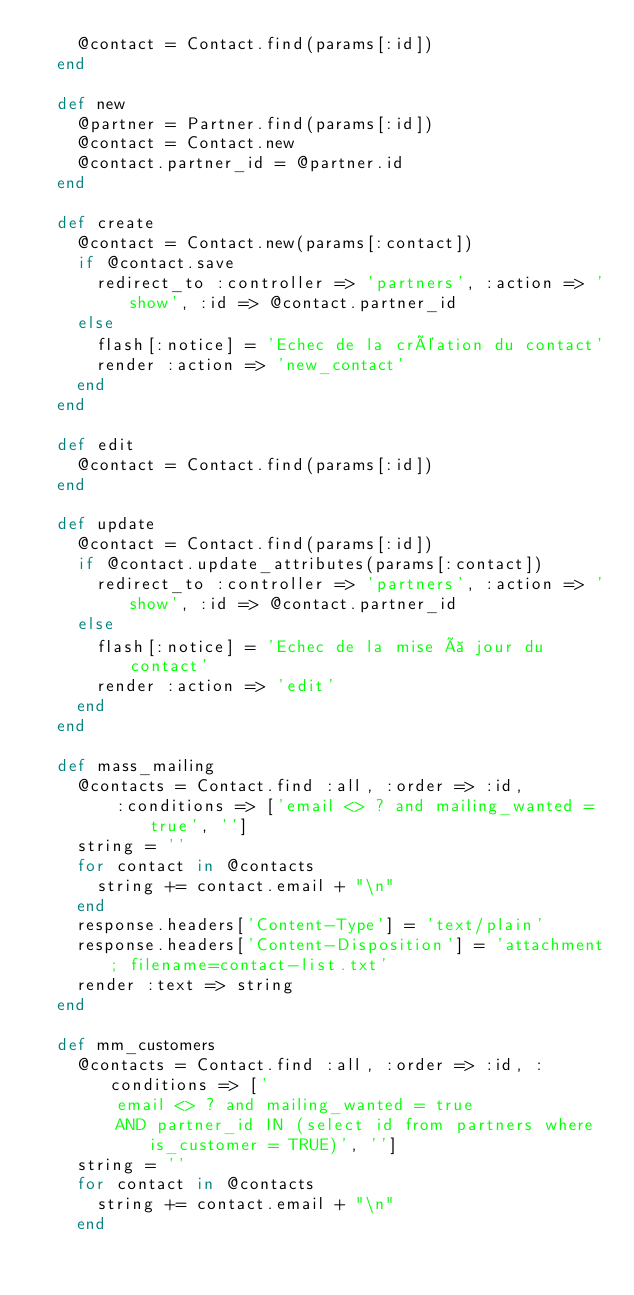Convert code to text. <code><loc_0><loc_0><loc_500><loc_500><_Ruby_>    @contact = Contact.find(params[:id])
  end

  def new
    @partner = Partner.find(params[:id])
    @contact = Contact.new
    @contact.partner_id = @partner.id
  end

  def create
    @contact = Contact.new(params[:contact])
    if @contact.save
      redirect_to :controller => 'partners', :action => 'show', :id => @contact.partner_id
    else
      flash[:notice] = 'Echec de la création du contact'
      render :action => 'new_contact'
    end
  end

  def edit
    @contact = Contact.find(params[:id])
  end

  def update
    @contact = Contact.find(params[:id])
    if @contact.update_attributes(params[:contact])
      redirect_to :controller => 'partners', :action => 'show', :id => @contact.partner_id
    else
      flash[:notice] = 'Echec de la mise à jour du contact'
      render :action => 'edit'
    end
  end

  def mass_mailing
    @contacts = Contact.find :all, :order => :id,
		:conditions => ['email <> ? and mailing_wanted = true', '']
    string = ''
    for contact in @contacts
      string += contact.email + "\n"
    end
    response.headers['Content-Type'] = 'text/plain'
    response.headers['Content-Disposition'] = 'attachment; filename=contact-list.txt'
    render :text => string
  end

  def mm_customers
    @contacts = Contact.find :all, :order => :id, :conditions => ['
		email <> ? and mailing_wanted = true
		AND partner_id IN (select id from partners where is_customer = TRUE)', '']
    string = ''
    for contact in @contacts
      string += contact.email + "\n"
    end</code> 